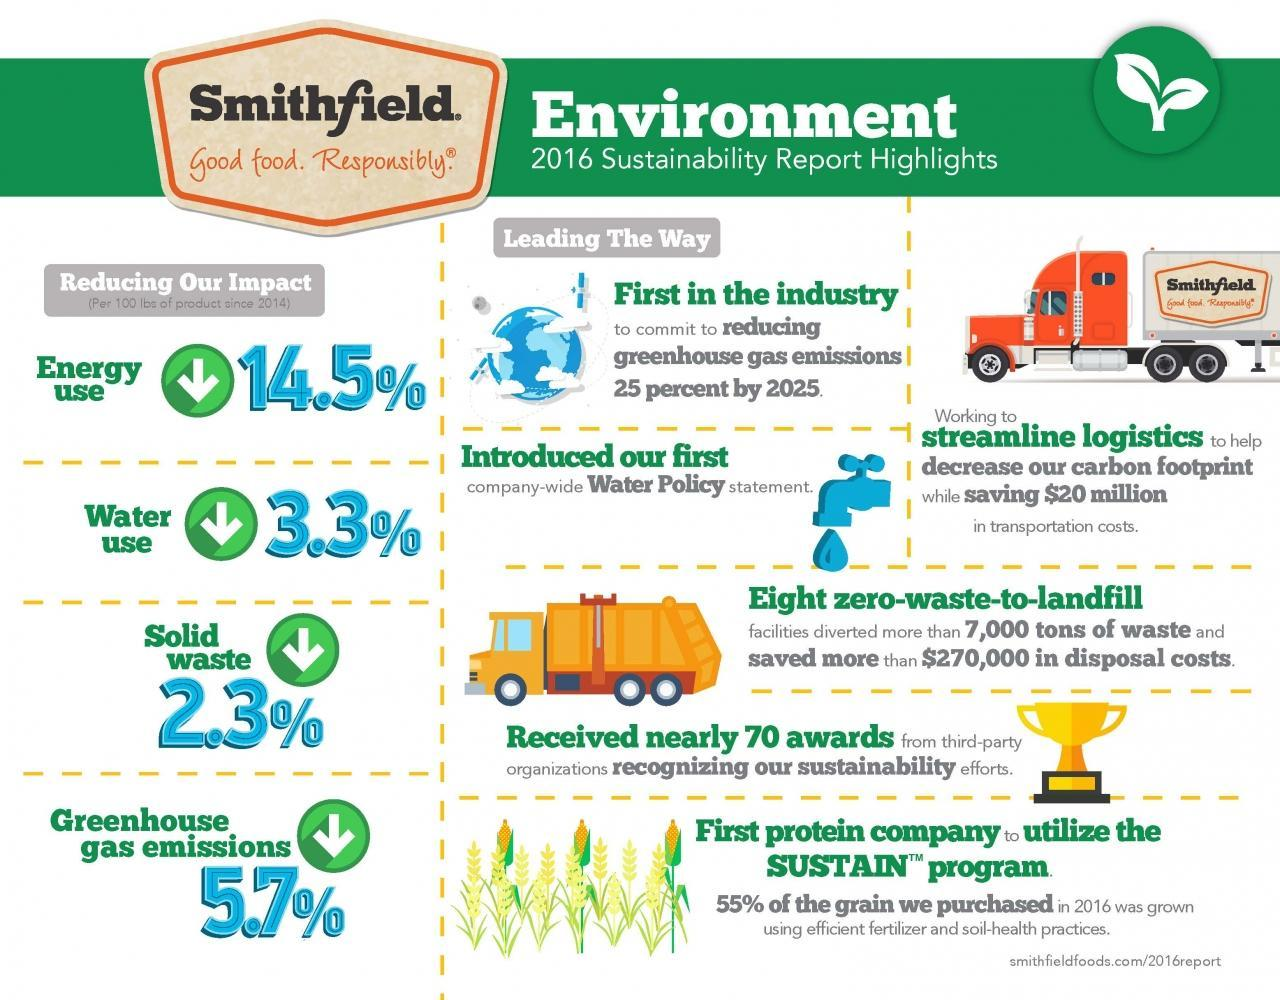How much energy use and water use is Smithfield trying to reduce?
Answer the question with a short phrase. 17.8% How many trucks are shown? 2 